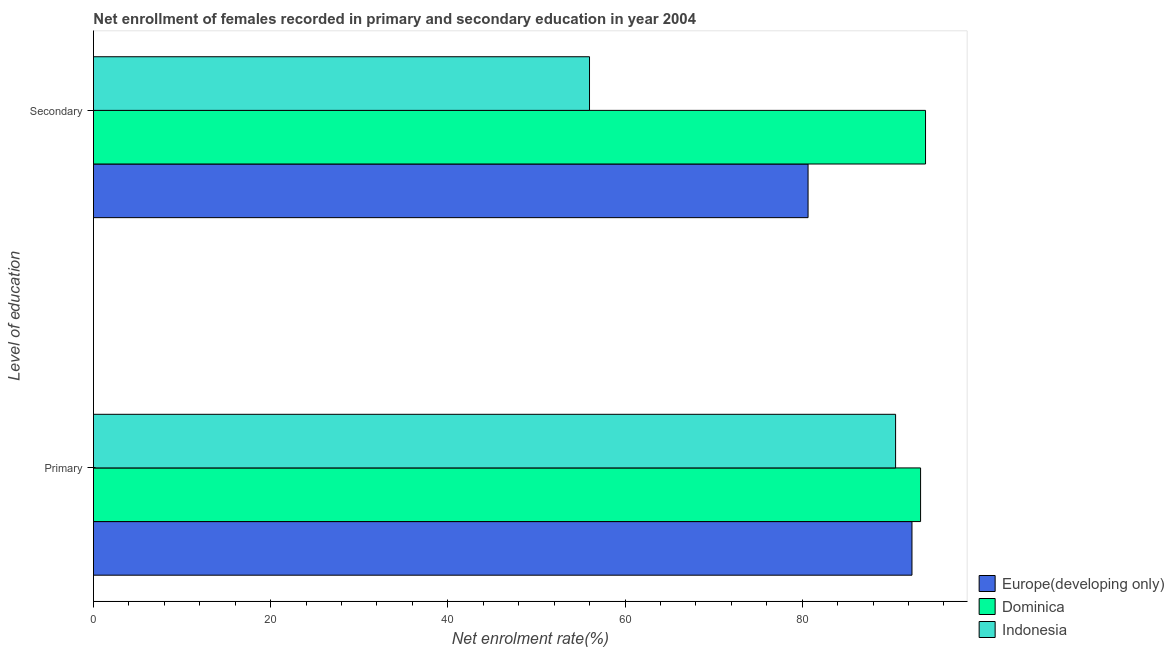How many different coloured bars are there?
Provide a short and direct response. 3. How many bars are there on the 1st tick from the top?
Give a very brief answer. 3. What is the label of the 2nd group of bars from the top?
Keep it short and to the point. Primary. What is the enrollment rate in primary education in Dominica?
Provide a short and direct response. 93.36. Across all countries, what is the maximum enrollment rate in secondary education?
Offer a terse response. 93.92. Across all countries, what is the minimum enrollment rate in secondary education?
Your answer should be very brief. 55.99. In which country was the enrollment rate in secondary education maximum?
Give a very brief answer. Dominica. In which country was the enrollment rate in secondary education minimum?
Offer a terse response. Indonesia. What is the total enrollment rate in primary education in the graph?
Provide a succinct answer. 276.29. What is the difference between the enrollment rate in primary education in Indonesia and that in Europe(developing only)?
Provide a succinct answer. -1.85. What is the difference between the enrollment rate in primary education in Indonesia and the enrollment rate in secondary education in Dominica?
Make the answer very short. -3.38. What is the average enrollment rate in secondary education per country?
Provide a short and direct response. 76.86. What is the difference between the enrollment rate in secondary education and enrollment rate in primary education in Dominica?
Your response must be concise. 0.56. In how many countries, is the enrollment rate in primary education greater than 44 %?
Keep it short and to the point. 3. What is the ratio of the enrollment rate in primary education in Europe(developing only) to that in Indonesia?
Provide a succinct answer. 1.02. Is the enrollment rate in secondary education in Europe(developing only) less than that in Dominica?
Give a very brief answer. Yes. What does the 3rd bar from the top in Primary represents?
Your response must be concise. Europe(developing only). What does the 2nd bar from the bottom in Secondary represents?
Provide a succinct answer. Dominica. How many bars are there?
Your answer should be compact. 6. Are all the bars in the graph horizontal?
Your response must be concise. Yes. How many countries are there in the graph?
Ensure brevity in your answer.  3. What is the difference between two consecutive major ticks on the X-axis?
Keep it short and to the point. 20. Are the values on the major ticks of X-axis written in scientific E-notation?
Provide a succinct answer. No. How many legend labels are there?
Give a very brief answer. 3. How are the legend labels stacked?
Offer a very short reply. Vertical. What is the title of the graph?
Offer a terse response. Net enrollment of females recorded in primary and secondary education in year 2004. What is the label or title of the X-axis?
Offer a very short reply. Net enrolment rate(%). What is the label or title of the Y-axis?
Offer a very short reply. Level of education. What is the Net enrolment rate(%) of Europe(developing only) in Primary?
Give a very brief answer. 92.39. What is the Net enrolment rate(%) in Dominica in Primary?
Keep it short and to the point. 93.36. What is the Net enrolment rate(%) in Indonesia in Primary?
Keep it short and to the point. 90.54. What is the Net enrolment rate(%) of Europe(developing only) in Secondary?
Provide a succinct answer. 80.66. What is the Net enrolment rate(%) of Dominica in Secondary?
Ensure brevity in your answer.  93.92. What is the Net enrolment rate(%) in Indonesia in Secondary?
Ensure brevity in your answer.  55.99. Across all Level of education, what is the maximum Net enrolment rate(%) in Europe(developing only)?
Provide a succinct answer. 92.39. Across all Level of education, what is the maximum Net enrolment rate(%) of Dominica?
Make the answer very short. 93.92. Across all Level of education, what is the maximum Net enrolment rate(%) of Indonesia?
Keep it short and to the point. 90.54. Across all Level of education, what is the minimum Net enrolment rate(%) in Europe(developing only)?
Your answer should be compact. 80.66. Across all Level of education, what is the minimum Net enrolment rate(%) of Dominica?
Give a very brief answer. 93.36. Across all Level of education, what is the minimum Net enrolment rate(%) of Indonesia?
Offer a terse response. 55.99. What is the total Net enrolment rate(%) of Europe(developing only) in the graph?
Make the answer very short. 173.05. What is the total Net enrolment rate(%) of Dominica in the graph?
Offer a terse response. 187.28. What is the total Net enrolment rate(%) of Indonesia in the graph?
Provide a succinct answer. 146.53. What is the difference between the Net enrolment rate(%) of Europe(developing only) in Primary and that in Secondary?
Offer a terse response. 11.73. What is the difference between the Net enrolment rate(%) of Dominica in Primary and that in Secondary?
Provide a succinct answer. -0.56. What is the difference between the Net enrolment rate(%) of Indonesia in Primary and that in Secondary?
Provide a short and direct response. 34.55. What is the difference between the Net enrolment rate(%) in Europe(developing only) in Primary and the Net enrolment rate(%) in Dominica in Secondary?
Your answer should be compact. -1.53. What is the difference between the Net enrolment rate(%) in Europe(developing only) in Primary and the Net enrolment rate(%) in Indonesia in Secondary?
Offer a very short reply. 36.4. What is the difference between the Net enrolment rate(%) of Dominica in Primary and the Net enrolment rate(%) of Indonesia in Secondary?
Ensure brevity in your answer.  37.37. What is the average Net enrolment rate(%) of Europe(developing only) per Level of education?
Provide a succinct answer. 86.52. What is the average Net enrolment rate(%) in Dominica per Level of education?
Your answer should be very brief. 93.64. What is the average Net enrolment rate(%) in Indonesia per Level of education?
Make the answer very short. 73.27. What is the difference between the Net enrolment rate(%) of Europe(developing only) and Net enrolment rate(%) of Dominica in Primary?
Offer a terse response. -0.97. What is the difference between the Net enrolment rate(%) in Europe(developing only) and Net enrolment rate(%) in Indonesia in Primary?
Ensure brevity in your answer.  1.85. What is the difference between the Net enrolment rate(%) in Dominica and Net enrolment rate(%) in Indonesia in Primary?
Offer a very short reply. 2.82. What is the difference between the Net enrolment rate(%) in Europe(developing only) and Net enrolment rate(%) in Dominica in Secondary?
Keep it short and to the point. -13.26. What is the difference between the Net enrolment rate(%) of Europe(developing only) and Net enrolment rate(%) of Indonesia in Secondary?
Offer a very short reply. 24.67. What is the difference between the Net enrolment rate(%) of Dominica and Net enrolment rate(%) of Indonesia in Secondary?
Provide a short and direct response. 37.93. What is the ratio of the Net enrolment rate(%) of Europe(developing only) in Primary to that in Secondary?
Ensure brevity in your answer.  1.15. What is the ratio of the Net enrolment rate(%) in Dominica in Primary to that in Secondary?
Provide a short and direct response. 0.99. What is the ratio of the Net enrolment rate(%) in Indonesia in Primary to that in Secondary?
Ensure brevity in your answer.  1.62. What is the difference between the highest and the second highest Net enrolment rate(%) in Europe(developing only)?
Ensure brevity in your answer.  11.73. What is the difference between the highest and the second highest Net enrolment rate(%) of Dominica?
Ensure brevity in your answer.  0.56. What is the difference between the highest and the second highest Net enrolment rate(%) of Indonesia?
Your response must be concise. 34.55. What is the difference between the highest and the lowest Net enrolment rate(%) in Europe(developing only)?
Provide a succinct answer. 11.73. What is the difference between the highest and the lowest Net enrolment rate(%) of Dominica?
Give a very brief answer. 0.56. What is the difference between the highest and the lowest Net enrolment rate(%) of Indonesia?
Keep it short and to the point. 34.55. 